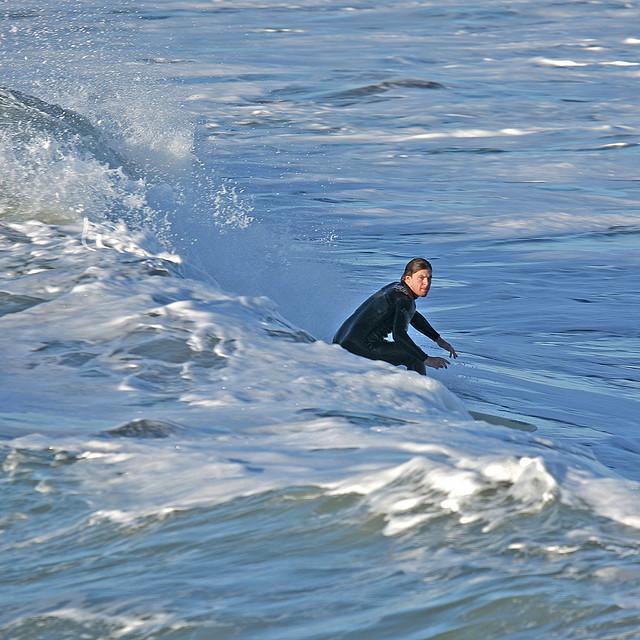How many surfers in the water?
Give a very brief answer. 1. 